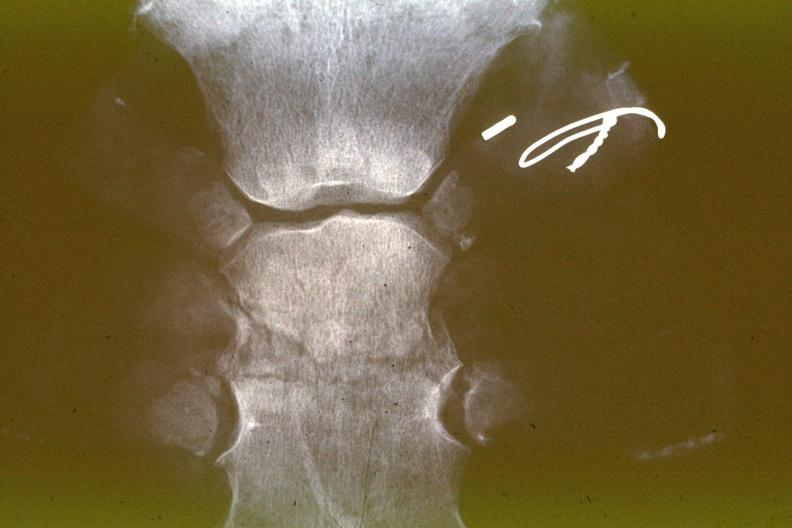what is present?
Answer the question using a single word or phrase. Joints 